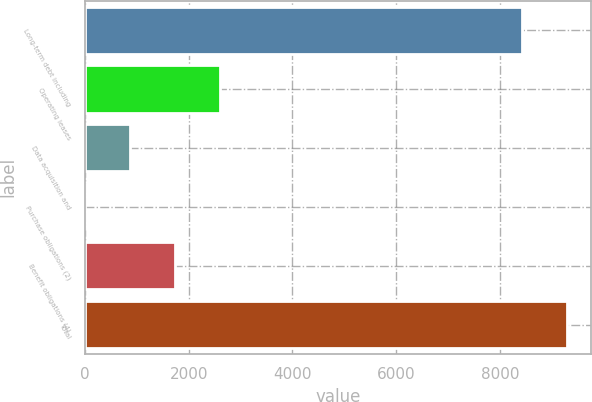Convert chart. <chart><loc_0><loc_0><loc_500><loc_500><bar_chart><fcel>Long-term debt including<fcel>Operating leases<fcel>Data acquisition and<fcel>Purchase obligations (2)<fcel>Benefit obligations (4)<fcel>Total<nl><fcel>8429<fcel>2604.9<fcel>870.3<fcel>3<fcel>1737.6<fcel>9296.3<nl></chart> 